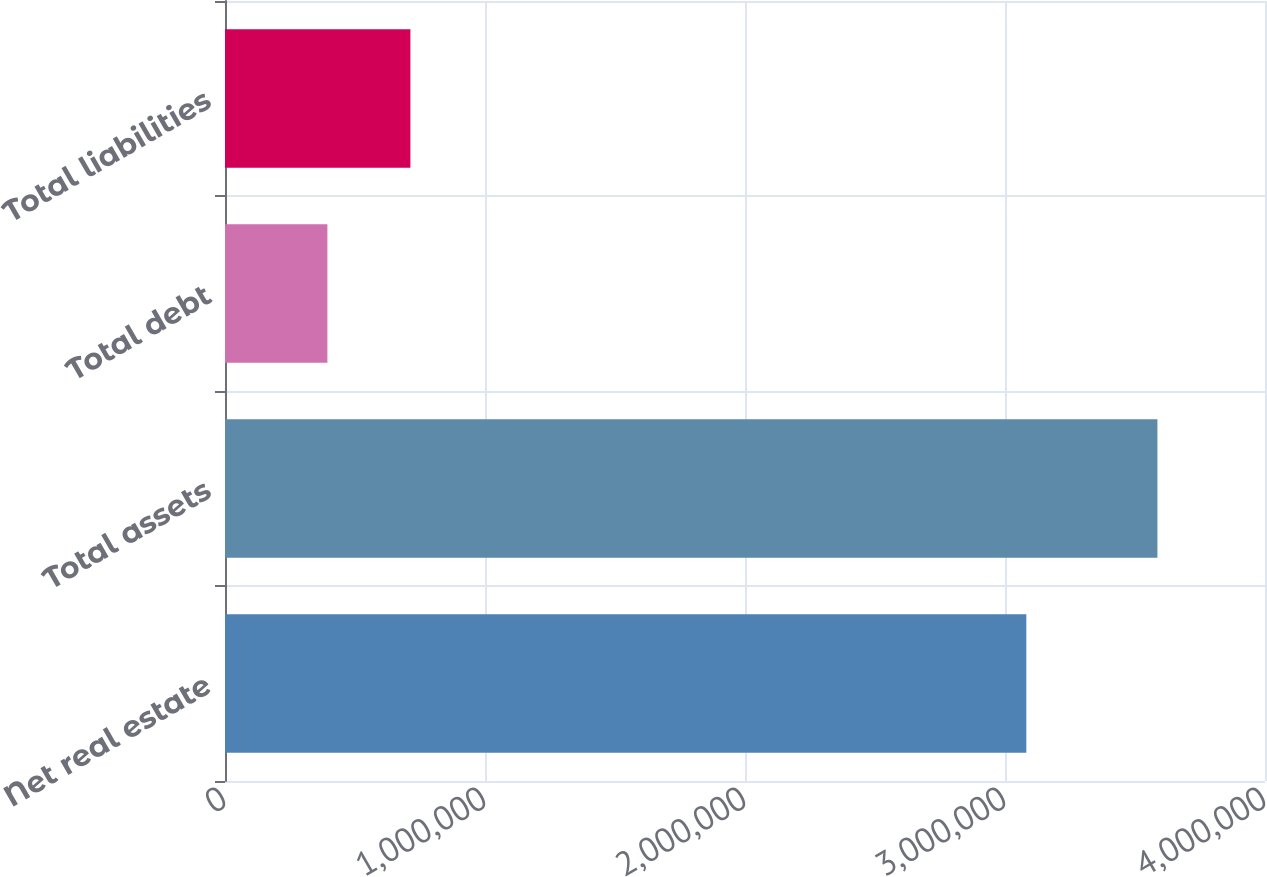<chart> <loc_0><loc_0><loc_500><loc_500><bar_chart><fcel>Net real estate<fcel>Total assets<fcel>Total debt<fcel>Total liabilities<nl><fcel>3.08202e+06<fcel>3.58624e+06<fcel>393812<fcel>713055<nl></chart> 